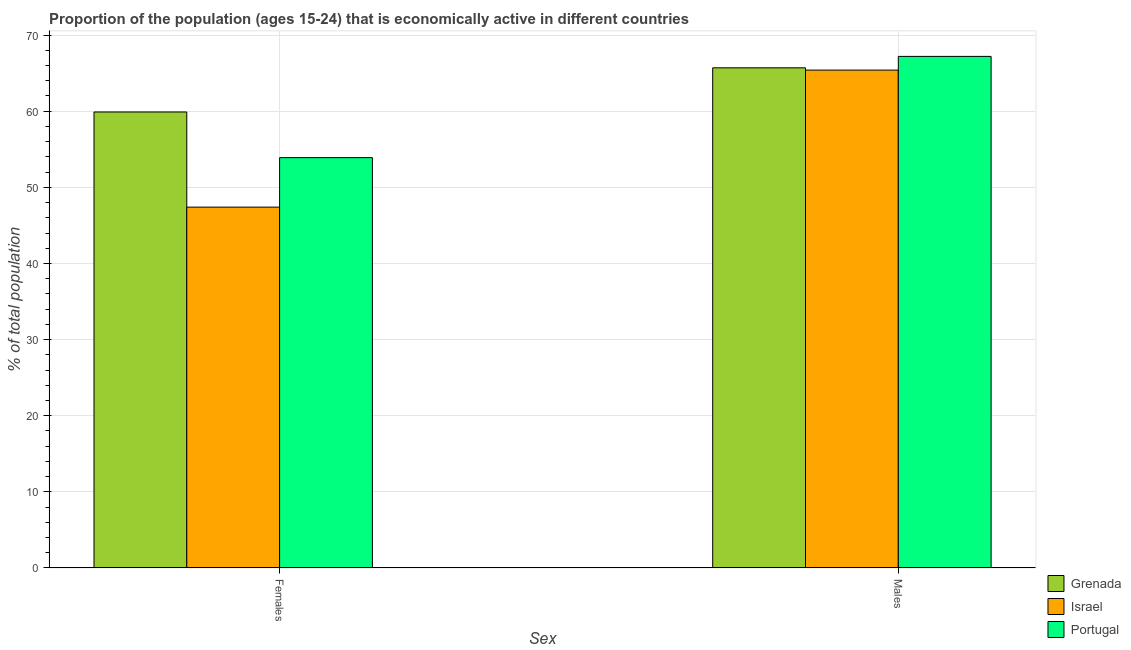How many bars are there on the 2nd tick from the left?
Keep it short and to the point. 3. How many bars are there on the 2nd tick from the right?
Ensure brevity in your answer.  3. What is the label of the 2nd group of bars from the left?
Ensure brevity in your answer.  Males. What is the percentage of economically active female population in Portugal?
Keep it short and to the point. 53.9. Across all countries, what is the maximum percentage of economically active male population?
Your response must be concise. 67.2. Across all countries, what is the minimum percentage of economically active male population?
Your answer should be very brief. 65.4. In which country was the percentage of economically active female population maximum?
Offer a very short reply. Grenada. In which country was the percentage of economically active female population minimum?
Your answer should be very brief. Israel. What is the total percentage of economically active male population in the graph?
Give a very brief answer. 198.3. What is the difference between the percentage of economically active female population in Portugal and the percentage of economically active male population in Grenada?
Your answer should be very brief. -11.8. What is the average percentage of economically active male population per country?
Provide a succinct answer. 66.1. What is the difference between the percentage of economically active female population and percentage of economically active male population in Israel?
Your answer should be compact. -18. In how many countries, is the percentage of economically active male population greater than 54 %?
Your response must be concise. 3. What is the ratio of the percentage of economically active male population in Israel to that in Portugal?
Ensure brevity in your answer.  0.97. Is the percentage of economically active male population in Israel less than that in Grenada?
Make the answer very short. Yes. In how many countries, is the percentage of economically active female population greater than the average percentage of economically active female population taken over all countries?
Keep it short and to the point. 2. What does the 3rd bar from the left in Females represents?
Your response must be concise. Portugal. What does the 3rd bar from the right in Males represents?
Provide a succinct answer. Grenada. How many bars are there?
Offer a terse response. 6. Are all the bars in the graph horizontal?
Give a very brief answer. No. How many countries are there in the graph?
Offer a terse response. 3. What is the difference between two consecutive major ticks on the Y-axis?
Offer a very short reply. 10. Are the values on the major ticks of Y-axis written in scientific E-notation?
Offer a terse response. No. Does the graph contain any zero values?
Offer a terse response. No. Does the graph contain grids?
Provide a succinct answer. Yes. What is the title of the graph?
Provide a succinct answer. Proportion of the population (ages 15-24) that is economically active in different countries. Does "Ghana" appear as one of the legend labels in the graph?
Your response must be concise. No. What is the label or title of the X-axis?
Make the answer very short. Sex. What is the label or title of the Y-axis?
Your answer should be very brief. % of total population. What is the % of total population in Grenada in Females?
Ensure brevity in your answer.  59.9. What is the % of total population in Israel in Females?
Keep it short and to the point. 47.4. What is the % of total population of Portugal in Females?
Your answer should be compact. 53.9. What is the % of total population in Grenada in Males?
Ensure brevity in your answer.  65.7. What is the % of total population in Israel in Males?
Make the answer very short. 65.4. What is the % of total population of Portugal in Males?
Offer a terse response. 67.2. Across all Sex, what is the maximum % of total population in Grenada?
Offer a terse response. 65.7. Across all Sex, what is the maximum % of total population of Israel?
Offer a terse response. 65.4. Across all Sex, what is the maximum % of total population of Portugal?
Offer a terse response. 67.2. Across all Sex, what is the minimum % of total population in Grenada?
Your answer should be compact. 59.9. Across all Sex, what is the minimum % of total population in Israel?
Make the answer very short. 47.4. Across all Sex, what is the minimum % of total population of Portugal?
Offer a very short reply. 53.9. What is the total % of total population of Grenada in the graph?
Provide a succinct answer. 125.6. What is the total % of total population of Israel in the graph?
Your answer should be very brief. 112.8. What is the total % of total population of Portugal in the graph?
Your answer should be very brief. 121.1. What is the difference between the % of total population of Israel in Females and that in Males?
Make the answer very short. -18. What is the difference between the % of total population of Portugal in Females and that in Males?
Offer a terse response. -13.3. What is the difference between the % of total population in Grenada in Females and the % of total population in Israel in Males?
Your answer should be compact. -5.5. What is the difference between the % of total population of Grenada in Females and the % of total population of Portugal in Males?
Give a very brief answer. -7.3. What is the difference between the % of total population in Israel in Females and the % of total population in Portugal in Males?
Your answer should be compact. -19.8. What is the average % of total population of Grenada per Sex?
Your response must be concise. 62.8. What is the average % of total population of Israel per Sex?
Your response must be concise. 56.4. What is the average % of total population in Portugal per Sex?
Your answer should be compact. 60.55. What is the difference between the % of total population of Grenada and % of total population of Israel in Females?
Provide a succinct answer. 12.5. What is the difference between the % of total population in Grenada and % of total population in Portugal in Females?
Your answer should be compact. 6. What is the difference between the % of total population in Israel and % of total population in Portugal in Females?
Offer a terse response. -6.5. What is the ratio of the % of total population of Grenada in Females to that in Males?
Give a very brief answer. 0.91. What is the ratio of the % of total population of Israel in Females to that in Males?
Make the answer very short. 0.72. What is the ratio of the % of total population of Portugal in Females to that in Males?
Make the answer very short. 0.8. What is the difference between the highest and the second highest % of total population of Grenada?
Ensure brevity in your answer.  5.8. What is the difference between the highest and the second highest % of total population in Portugal?
Your answer should be compact. 13.3. What is the difference between the highest and the lowest % of total population of Grenada?
Provide a succinct answer. 5.8. What is the difference between the highest and the lowest % of total population of Israel?
Your answer should be compact. 18. What is the difference between the highest and the lowest % of total population in Portugal?
Give a very brief answer. 13.3. 